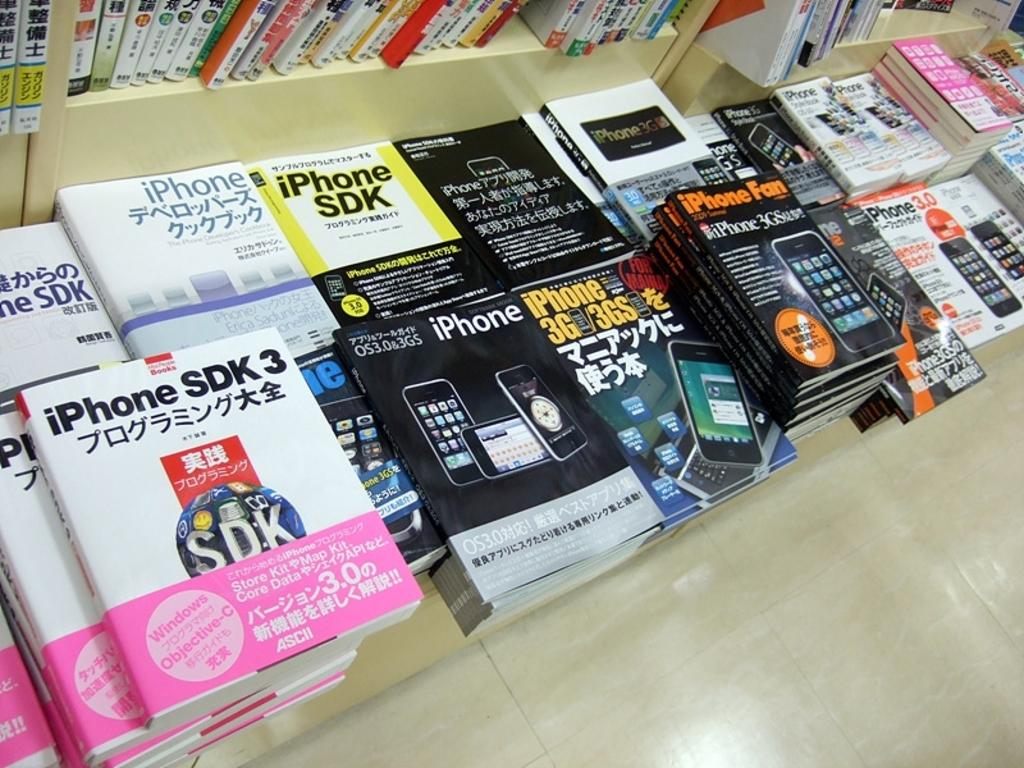<image>
Describe the image concisely. A large pile of different books about iPhones. 